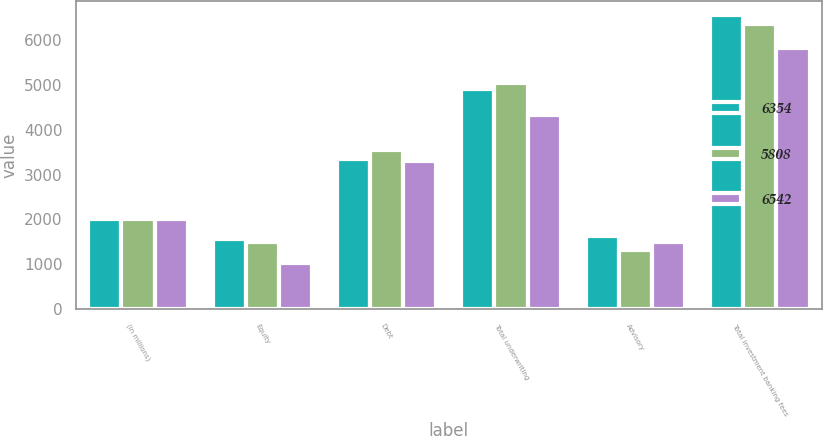Convert chart to OTSL. <chart><loc_0><loc_0><loc_500><loc_500><stacked_bar_chart><ecel><fcel>(in millions)<fcel>Equity<fcel>Debt<fcel>Total underwriting<fcel>Advisory<fcel>Total investment banking fees<nl><fcel>6354<fcel>2014<fcel>1571<fcel>3340<fcel>4911<fcel>1631<fcel>6542<nl><fcel>5808<fcel>2013<fcel>1499<fcel>3537<fcel>5036<fcel>1318<fcel>6354<nl><fcel>6542<fcel>2012<fcel>1026<fcel>3290<fcel>4316<fcel>1492<fcel>5808<nl></chart> 